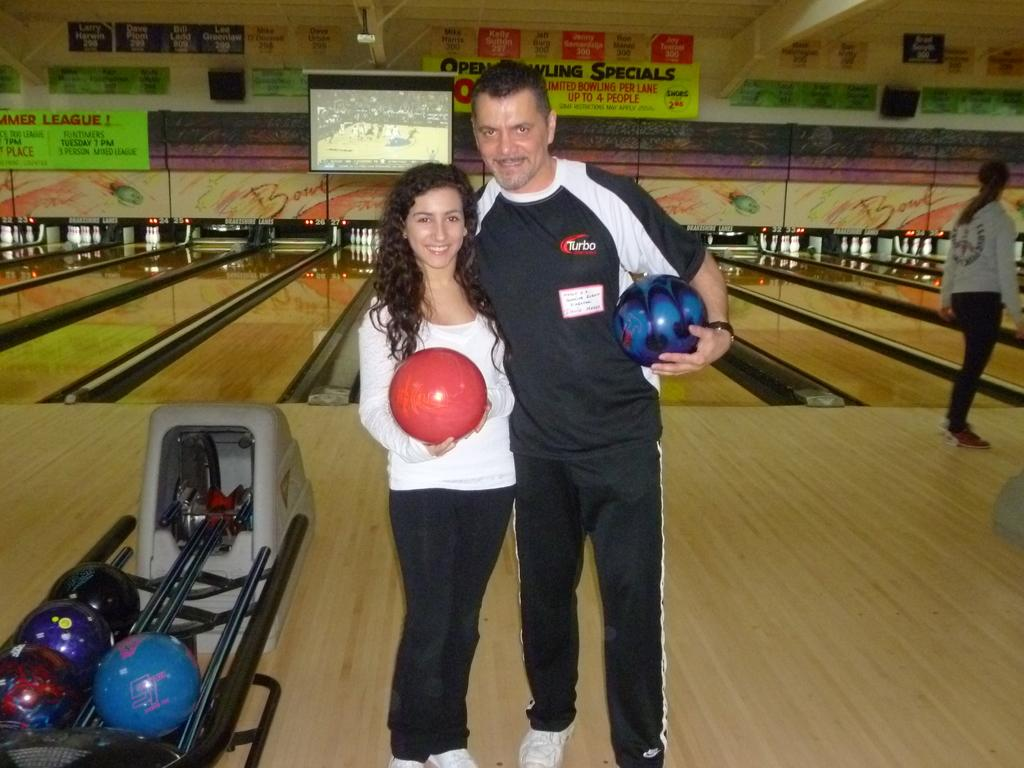<image>
Share a concise interpretation of the image provided. A man and women holding bowling balls, with a billboard in the background that says bowling specials 